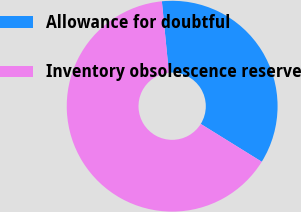Convert chart. <chart><loc_0><loc_0><loc_500><loc_500><pie_chart><fcel>Allowance for doubtful<fcel>Inventory obsolescence reserve<nl><fcel>35.39%<fcel>64.61%<nl></chart> 